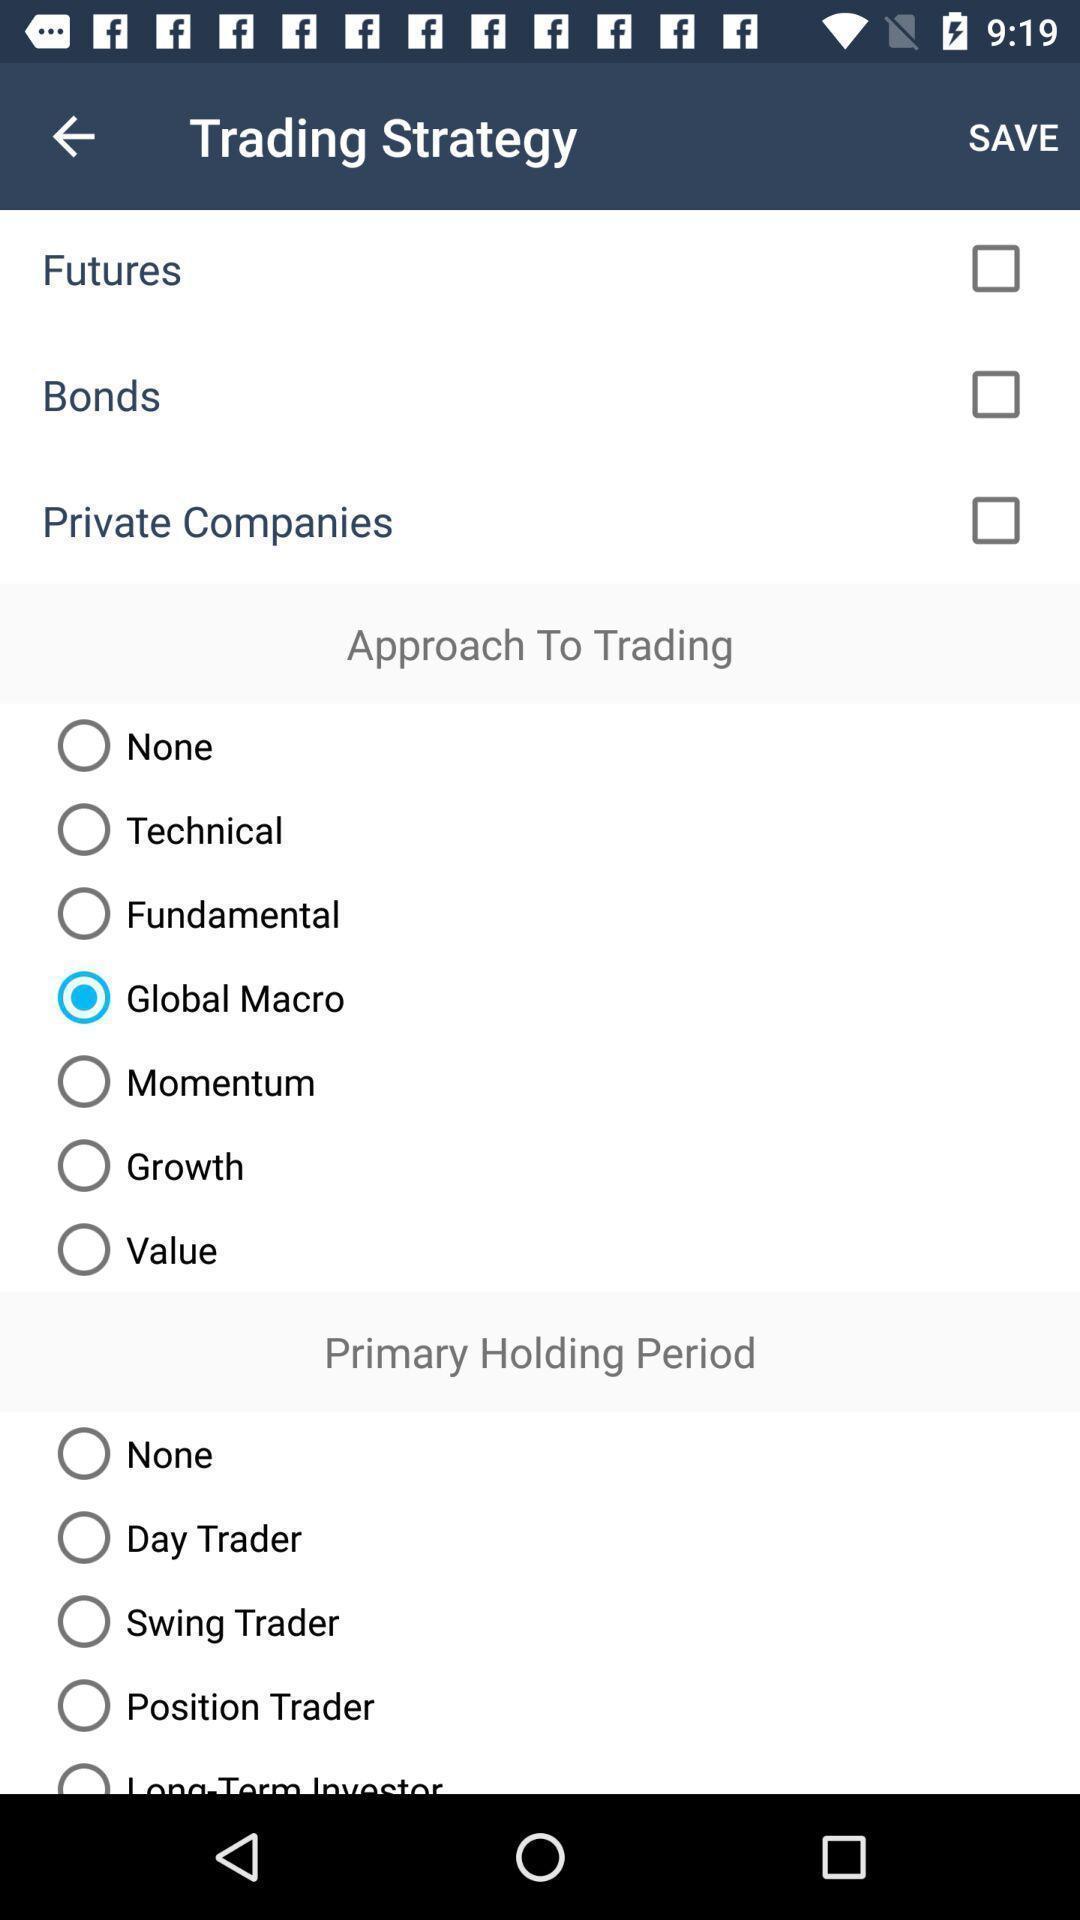What can you discern from this picture? Screen displaying multiple trading options. 